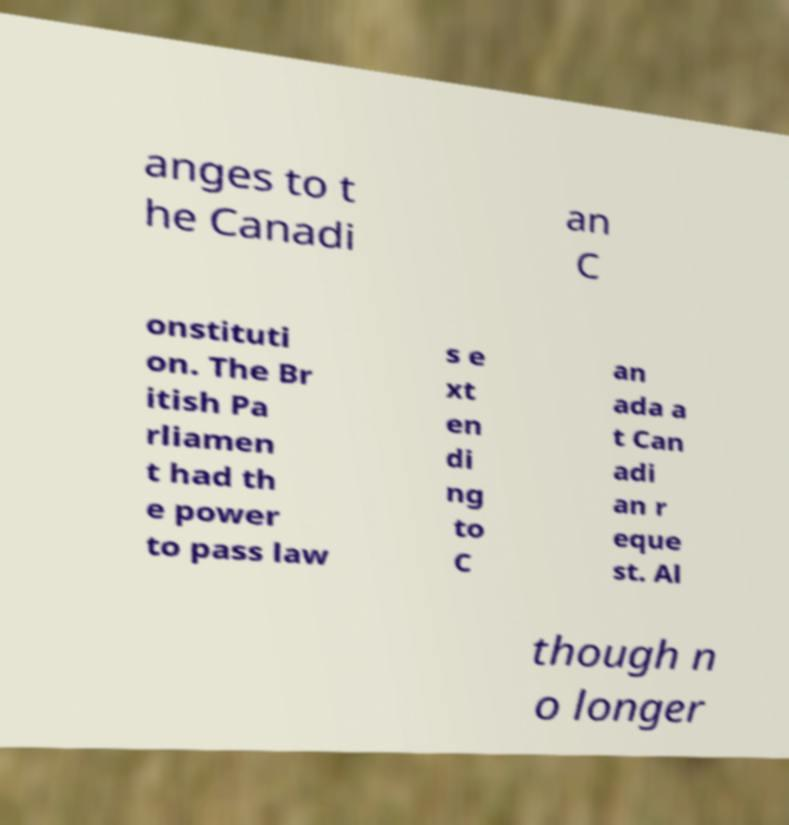What messages or text are displayed in this image? I need them in a readable, typed format. anges to t he Canadi an C onstituti on. The Br itish Pa rliamen t had th e power to pass law s e xt en di ng to C an ada a t Can adi an r eque st. Al though n o longer 